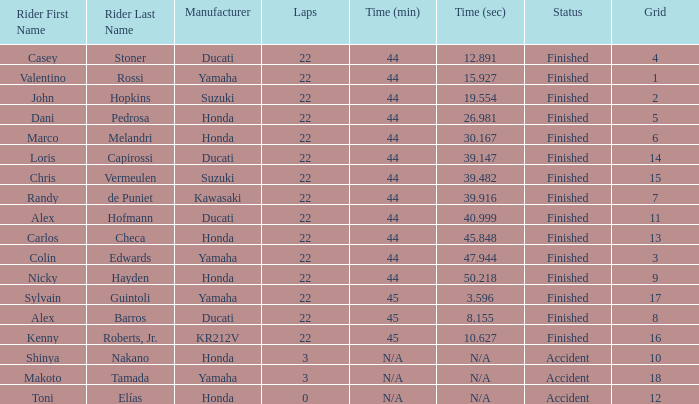What is the average grid for the competitiors who had laps smaller than 3? 12.0. 